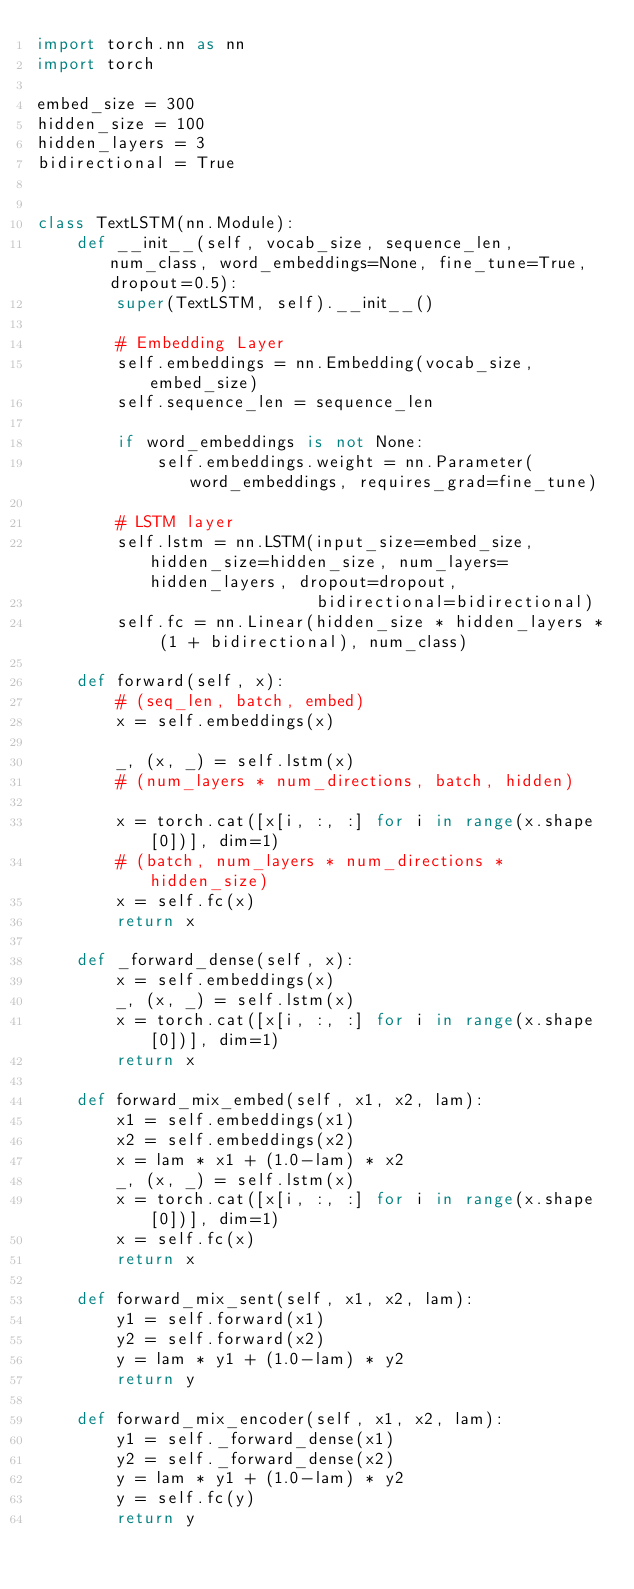Convert code to text. <code><loc_0><loc_0><loc_500><loc_500><_Python_>import torch.nn as nn
import torch

embed_size = 300
hidden_size = 100
hidden_layers = 3
bidirectional = True


class TextLSTM(nn.Module):
    def __init__(self, vocab_size, sequence_len, num_class, word_embeddings=None, fine_tune=True, dropout=0.5):
        super(TextLSTM, self).__init__()

        # Embedding Layer
        self.embeddings = nn.Embedding(vocab_size, embed_size)
        self.sequence_len = sequence_len

        if word_embeddings is not None:
            self.embeddings.weight = nn.Parameter(word_embeddings, requires_grad=fine_tune)

        # LSTM layer
        self.lstm = nn.LSTM(input_size=embed_size, hidden_size=hidden_size, num_layers=hidden_layers, dropout=dropout,
                            bidirectional=bidirectional)
        self.fc = nn.Linear(hidden_size * hidden_layers * (1 + bidirectional), num_class)

    def forward(self, x):
        # (seq_len, batch, embed)
        x = self.embeddings(x)

        _, (x, _) = self.lstm(x)
        # (num_layers * num_directions, batch, hidden)

        x = torch.cat([x[i, :, :] for i in range(x.shape[0])], dim=1)
        # (batch, num_layers * num_directions * hidden_size)
        x = self.fc(x)
        return x

    def _forward_dense(self, x):
        x = self.embeddings(x)
        _, (x, _) = self.lstm(x)
        x = torch.cat([x[i, :, :] for i in range(x.shape[0])], dim=1)
        return x

    def forward_mix_embed(self, x1, x2, lam):
        x1 = self.embeddings(x1)
        x2 = self.embeddings(x2)
        x = lam * x1 + (1.0-lam) * x2
        _, (x, _) = self.lstm(x)
        x = torch.cat([x[i, :, :] for i in range(x.shape[0])], dim=1)
        x = self.fc(x)
        return x

    def forward_mix_sent(self, x1, x2, lam):
        y1 = self.forward(x1)
        y2 = self.forward(x2)
        y = lam * y1 + (1.0-lam) * y2
        return y

    def forward_mix_encoder(self, x1, x2, lam):
        y1 = self._forward_dense(x1)
        y2 = self._forward_dense(x2)
        y = lam * y1 + (1.0-lam) * y2
        y = self.fc(y)
        return y
</code> 